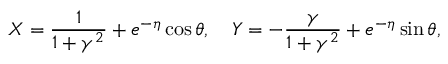<formula> <loc_0><loc_0><loc_500><loc_500>X = \frac { 1 } { 1 + \gamma ^ { 2 } } + e ^ { - \eta } \cos \theta , \quad Y = - \frac { \gamma } { 1 + \gamma ^ { 2 } } + e ^ { - \eta } \sin \theta ,</formula> 